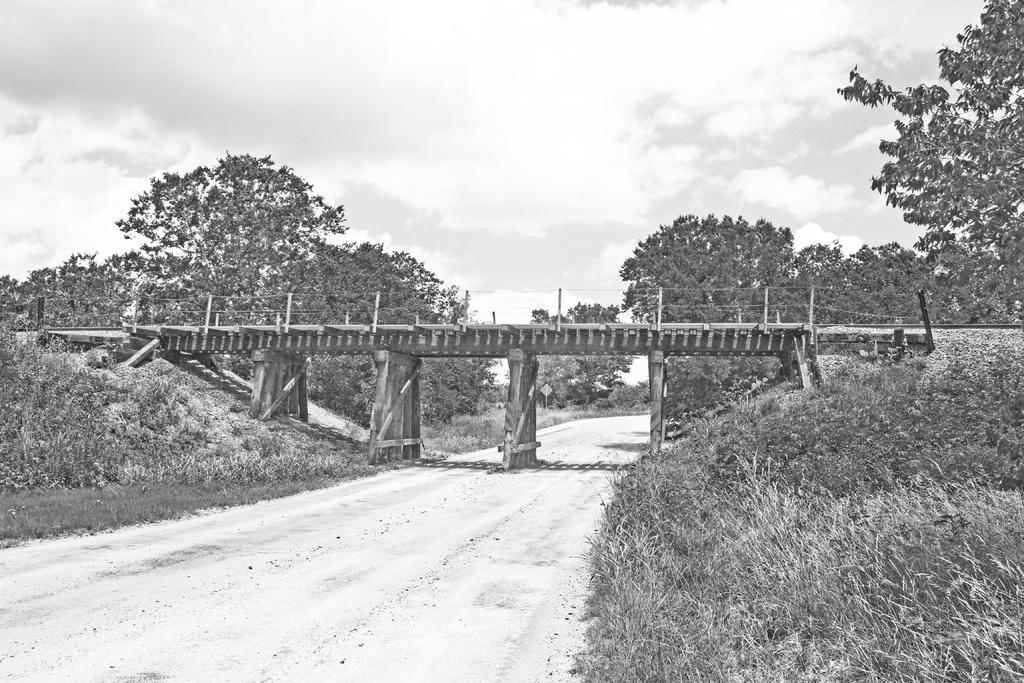Could you give a brief overview of what you see in this image? In the foreground of this black and white image, there is a road. On either side, there is grass. In the middle, there is a bridge. In the background, there are trees and the sky. 